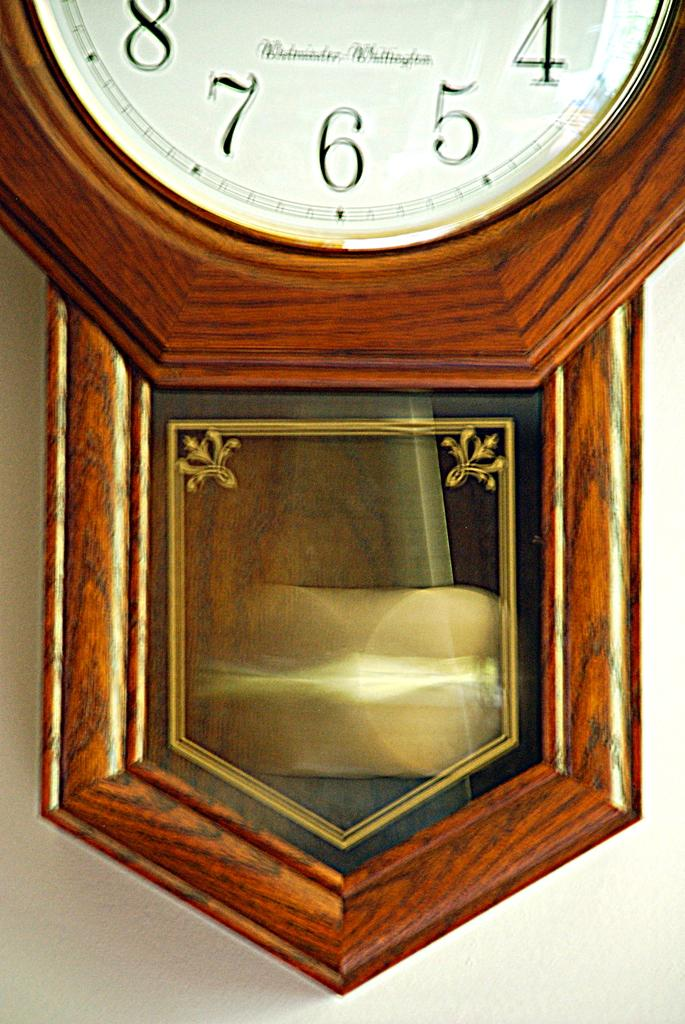<image>
Create a compact narrative representing the image presented. Old clock that has the name "Wilmington" on the bottom. 